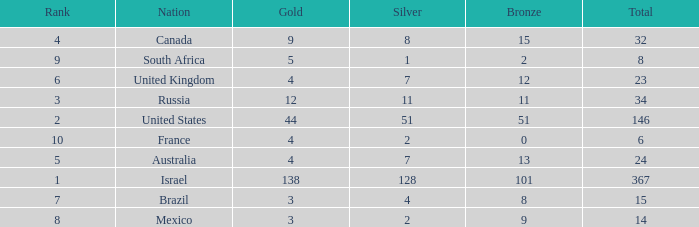What is the maximum number of silvers for a country with fewer than 12 golds and a total less than 8? 2.0. 